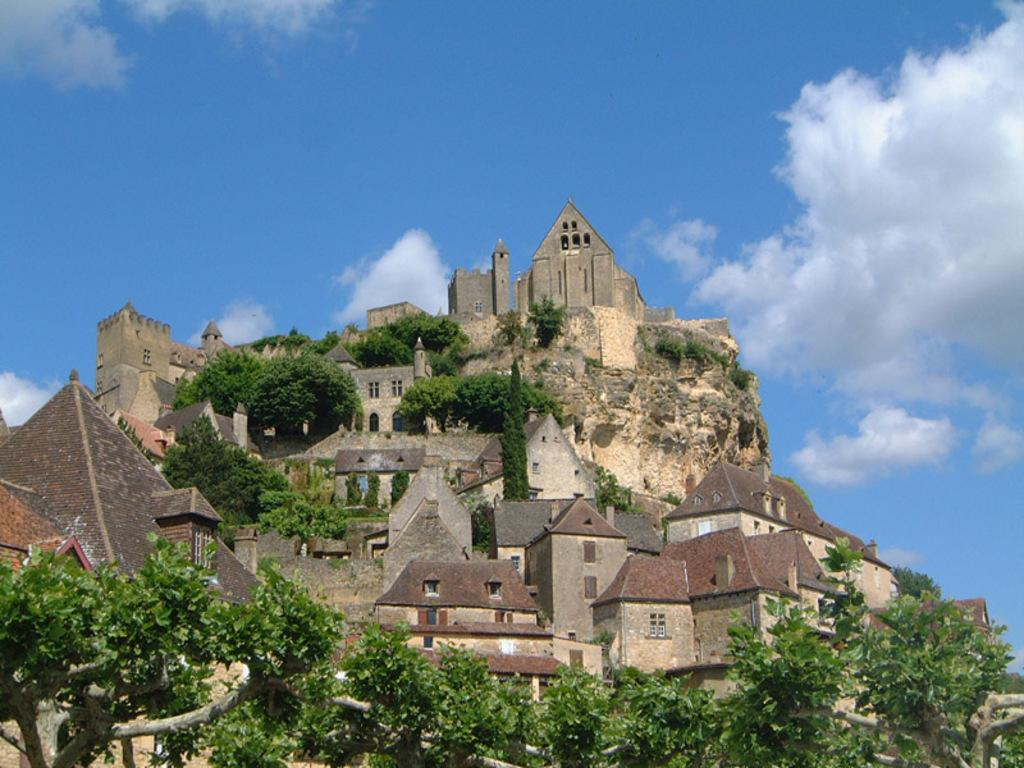What type of natural elements can be seen in the image? There are trees in the image. What type of man-made structures are present in the image? There are buildings in the image. What is visible at the top of the image? The sky is visible at the top of the image. What can be observed in the sky? There are clouds in the sky. What type of juice is being served to the group during the earthquake in the image? There is no juice, group, or earthquake present in the image. The image features trees, buildings, the sky, and clouds. 